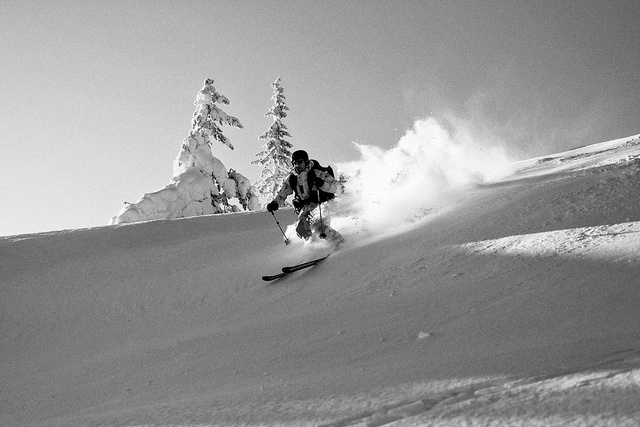Describe the objects in this image and their specific colors. I can see people in darkgray, black, gray, and lightgray tones, skis in black, gray, and darkgray tones, and backpack in darkgray, black, gray, and lightgray tones in this image. 